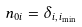Convert formula to latex. <formula><loc_0><loc_0><loc_500><loc_500>n _ { 0 i } = \delta _ { i , \, i _ { \min } }</formula> 